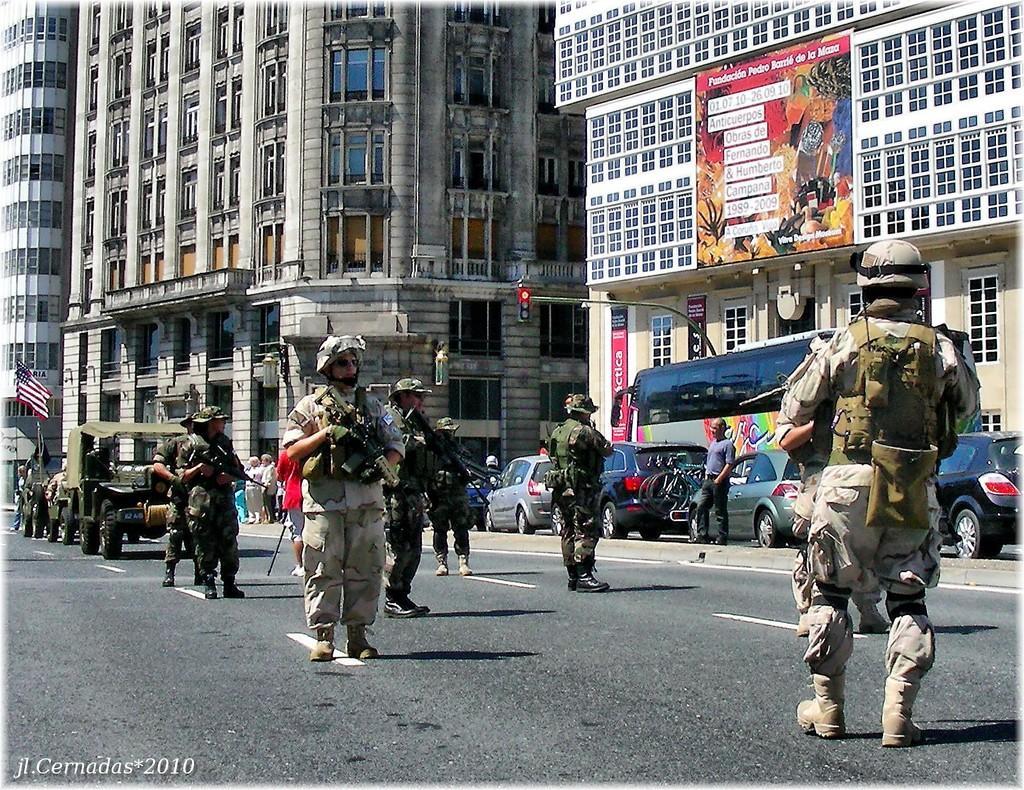Can you describe this image briefly? In this image we can see a few people, military officers are standing on the road, some of them are holding guns, we can see some vehicles, buildings, windows, pole, lights, traffic lights, board with some text written on it. 